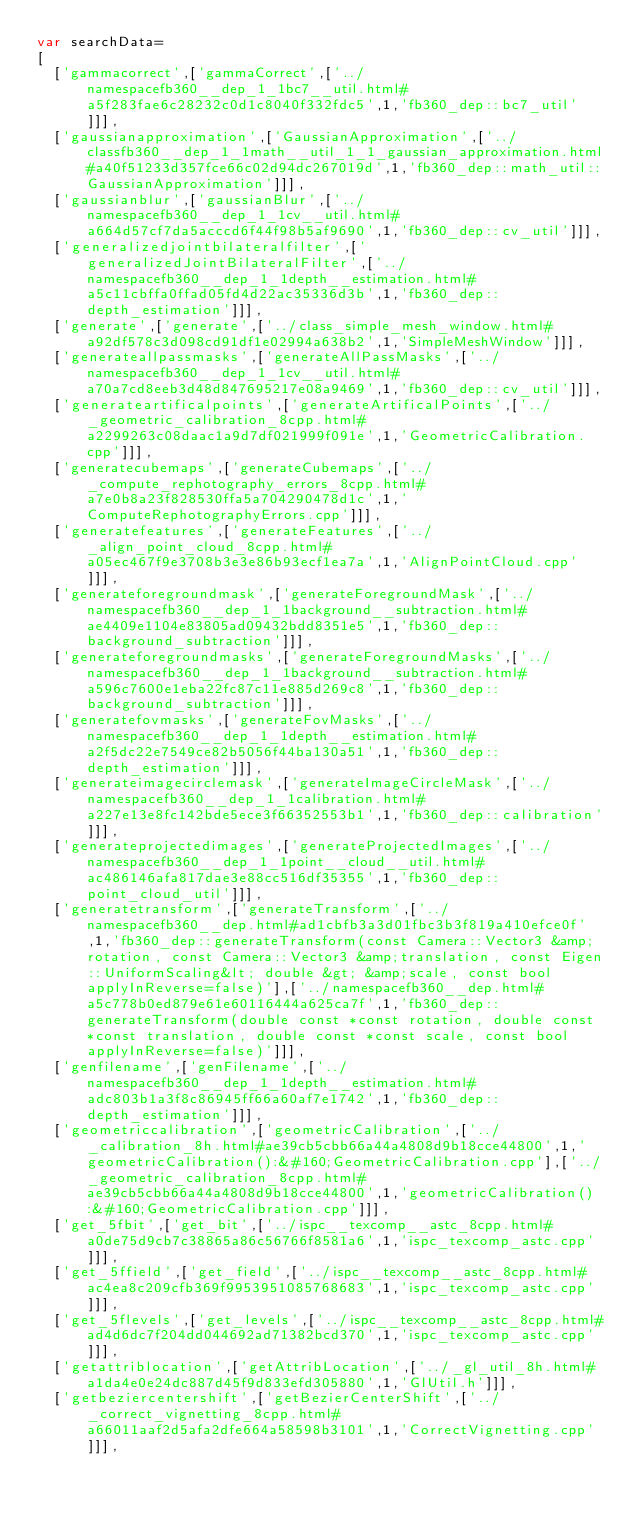<code> <loc_0><loc_0><loc_500><loc_500><_JavaScript_>var searchData=
[
  ['gammacorrect',['gammaCorrect',['../namespacefb360__dep_1_1bc7__util.html#a5f283fae6c28232c0d1c8040f332fdc5',1,'fb360_dep::bc7_util']]],
  ['gaussianapproximation',['GaussianApproximation',['../classfb360__dep_1_1math__util_1_1_gaussian_approximation.html#a40f51233d357fce66c02d94dc267019d',1,'fb360_dep::math_util::GaussianApproximation']]],
  ['gaussianblur',['gaussianBlur',['../namespacefb360__dep_1_1cv__util.html#a664d57cf7da5acccd6f44f98b5af9690',1,'fb360_dep::cv_util']]],
  ['generalizedjointbilateralfilter',['generalizedJointBilateralFilter',['../namespacefb360__dep_1_1depth__estimation.html#a5c11cbffa0ffad05fd4d22ac35336d3b',1,'fb360_dep::depth_estimation']]],
  ['generate',['generate',['../class_simple_mesh_window.html#a92df578c3d098cd91df1e02994a638b2',1,'SimpleMeshWindow']]],
  ['generateallpassmasks',['generateAllPassMasks',['../namespacefb360__dep_1_1cv__util.html#a70a7cd8eeb3d48d847695217e08a9469',1,'fb360_dep::cv_util']]],
  ['generateartificalpoints',['generateArtificalPoints',['../_geometric_calibration_8cpp.html#a2299263c08daac1a9d7df021999f091e',1,'GeometricCalibration.cpp']]],
  ['generatecubemaps',['generateCubemaps',['../_compute_rephotography_errors_8cpp.html#a7e0b8a23f828530ffa5a704290478d1c',1,'ComputeRephotographyErrors.cpp']]],
  ['generatefeatures',['generateFeatures',['../_align_point_cloud_8cpp.html#a05ec467f9e3708b3e3e86b93ecf1ea7a',1,'AlignPointCloud.cpp']]],
  ['generateforegroundmask',['generateForegroundMask',['../namespacefb360__dep_1_1background__subtraction.html#ae4409e1104e83805ad09432bdd8351e5',1,'fb360_dep::background_subtraction']]],
  ['generateforegroundmasks',['generateForegroundMasks',['../namespacefb360__dep_1_1background__subtraction.html#a596c7600e1eba22fc87c11e885d269c8',1,'fb360_dep::background_subtraction']]],
  ['generatefovmasks',['generateFovMasks',['../namespacefb360__dep_1_1depth__estimation.html#a2f5dc22e7549ce82b5056f44ba130a51',1,'fb360_dep::depth_estimation']]],
  ['generateimagecirclemask',['generateImageCircleMask',['../namespacefb360__dep_1_1calibration.html#a227e13e8fc142bde5ece3f66352553b1',1,'fb360_dep::calibration']]],
  ['generateprojectedimages',['generateProjectedImages',['../namespacefb360__dep_1_1point__cloud__util.html#ac486146afa817dae3e88cc516df35355',1,'fb360_dep::point_cloud_util']]],
  ['generatetransform',['generateTransform',['../namespacefb360__dep.html#ad1cbfb3a3d01fbc3b3f819a410efce0f',1,'fb360_dep::generateTransform(const Camera::Vector3 &amp;rotation, const Camera::Vector3 &amp;translation, const Eigen::UniformScaling&lt; double &gt; &amp;scale, const bool applyInReverse=false)'],['../namespacefb360__dep.html#a5c778b0ed879e61e60116444a625ca7f',1,'fb360_dep::generateTransform(double const *const rotation, double const *const translation, double const *const scale, const bool applyInReverse=false)']]],
  ['genfilename',['genFilename',['../namespacefb360__dep_1_1depth__estimation.html#adc803b1a3f8c86945ff66a60af7e1742',1,'fb360_dep::depth_estimation']]],
  ['geometriccalibration',['geometricCalibration',['../_calibration_8h.html#ae39cb5cbb66a44a4808d9b18cce44800',1,'geometricCalibration():&#160;GeometricCalibration.cpp'],['../_geometric_calibration_8cpp.html#ae39cb5cbb66a44a4808d9b18cce44800',1,'geometricCalibration():&#160;GeometricCalibration.cpp']]],
  ['get_5fbit',['get_bit',['../ispc__texcomp__astc_8cpp.html#a0de75d9cb7c38865a86c56766f8581a6',1,'ispc_texcomp_astc.cpp']]],
  ['get_5ffield',['get_field',['../ispc__texcomp__astc_8cpp.html#ac4ea8c209cfb369f9953951085768683',1,'ispc_texcomp_astc.cpp']]],
  ['get_5flevels',['get_levels',['../ispc__texcomp__astc_8cpp.html#ad4d6dc7f204dd044692ad71382bcd370',1,'ispc_texcomp_astc.cpp']]],
  ['getattriblocation',['getAttribLocation',['../_gl_util_8h.html#a1da4e0e24dc887d45f9d833efd305880',1,'GlUtil.h']]],
  ['getbeziercentershift',['getBezierCenterShift',['../_correct_vignetting_8cpp.html#a66011aaf2d5afa2dfe664a58598b3101',1,'CorrectVignetting.cpp']]],</code> 